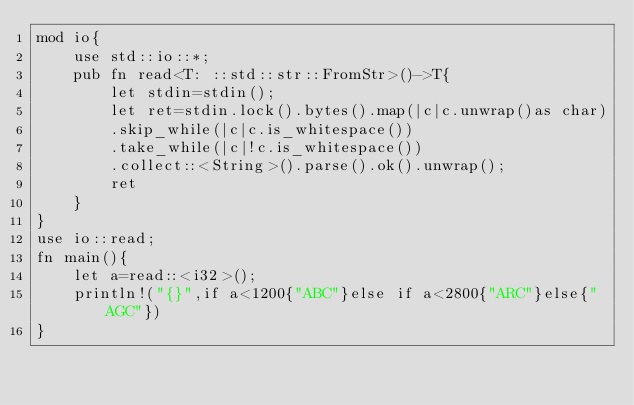<code> <loc_0><loc_0><loc_500><loc_500><_Rust_>mod io{
    use std::io::*;
    pub fn read<T: ::std::str::FromStr>()->T{
        let stdin=stdin();
        let ret=stdin.lock().bytes().map(|c|c.unwrap()as char)
        .skip_while(|c|c.is_whitespace())
        .take_while(|c|!c.is_whitespace())
        .collect::<String>().parse().ok().unwrap();
        ret
    }
}
use io::read;
fn main(){
    let a=read::<i32>();
    println!("{}",if a<1200{"ABC"}else if a<2800{"ARC"}else{"AGC"})
}
</code> 